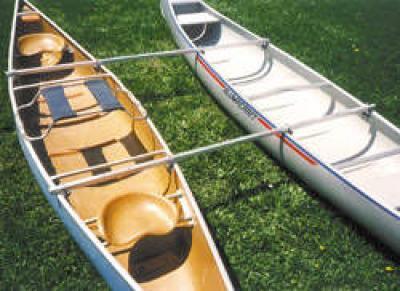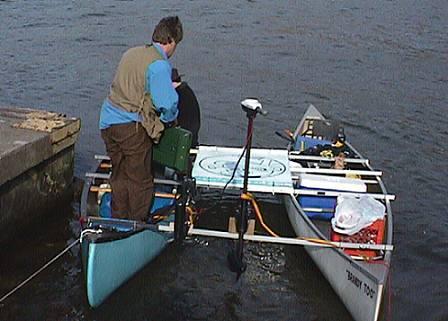The first image is the image on the left, the second image is the image on the right. Examine the images to the left and right. Is the description "One image shows side-by-side canoes joined with just two simple poles and not floating on water." accurate? Answer yes or no. Yes. 